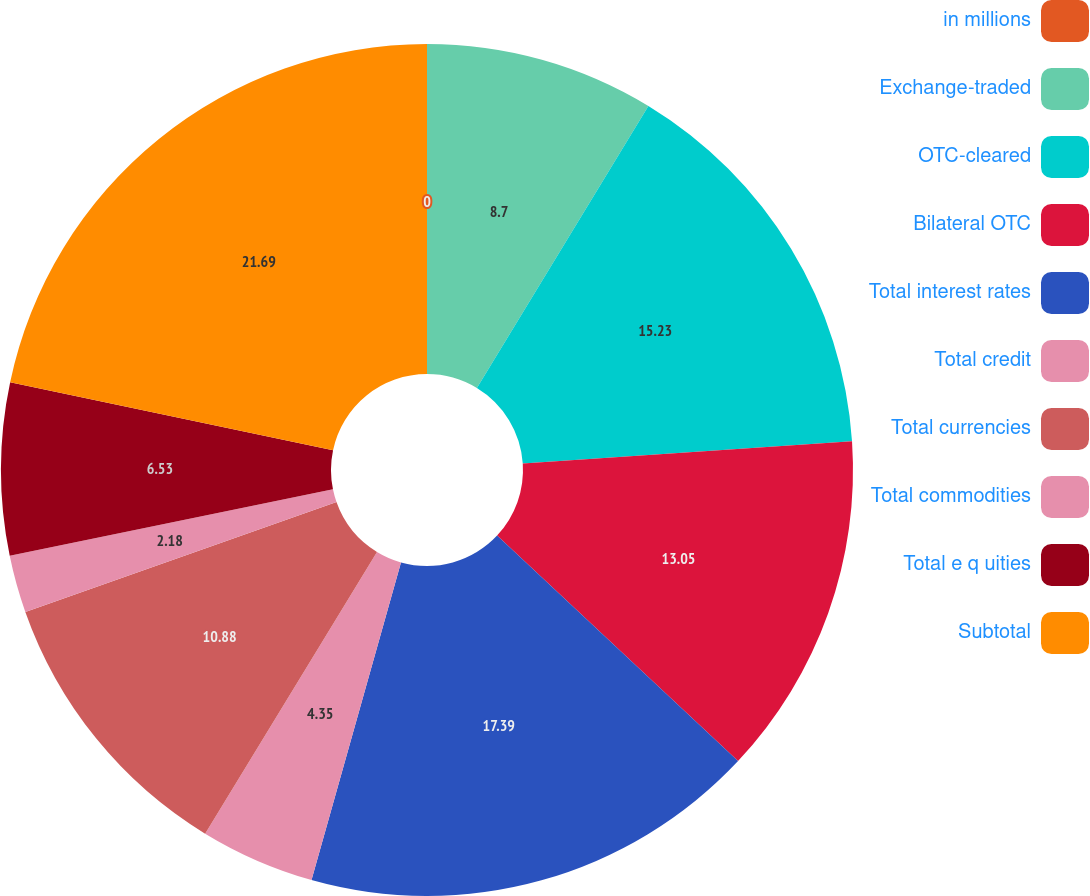Convert chart to OTSL. <chart><loc_0><loc_0><loc_500><loc_500><pie_chart><fcel>in millions<fcel>Exchange-traded<fcel>OTC-cleared<fcel>Bilateral OTC<fcel>Total interest rates<fcel>Total credit<fcel>Total currencies<fcel>Total commodities<fcel>Total e q uities<fcel>Subtotal<nl><fcel>0.0%<fcel>8.7%<fcel>15.23%<fcel>13.05%<fcel>17.4%<fcel>4.35%<fcel>10.88%<fcel>2.18%<fcel>6.53%<fcel>21.7%<nl></chart> 